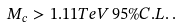Convert formula to latex. <formula><loc_0><loc_0><loc_500><loc_500>M _ { c } > 1 . 1 1 T e V \, 9 5 \% C . L . \, .</formula> 